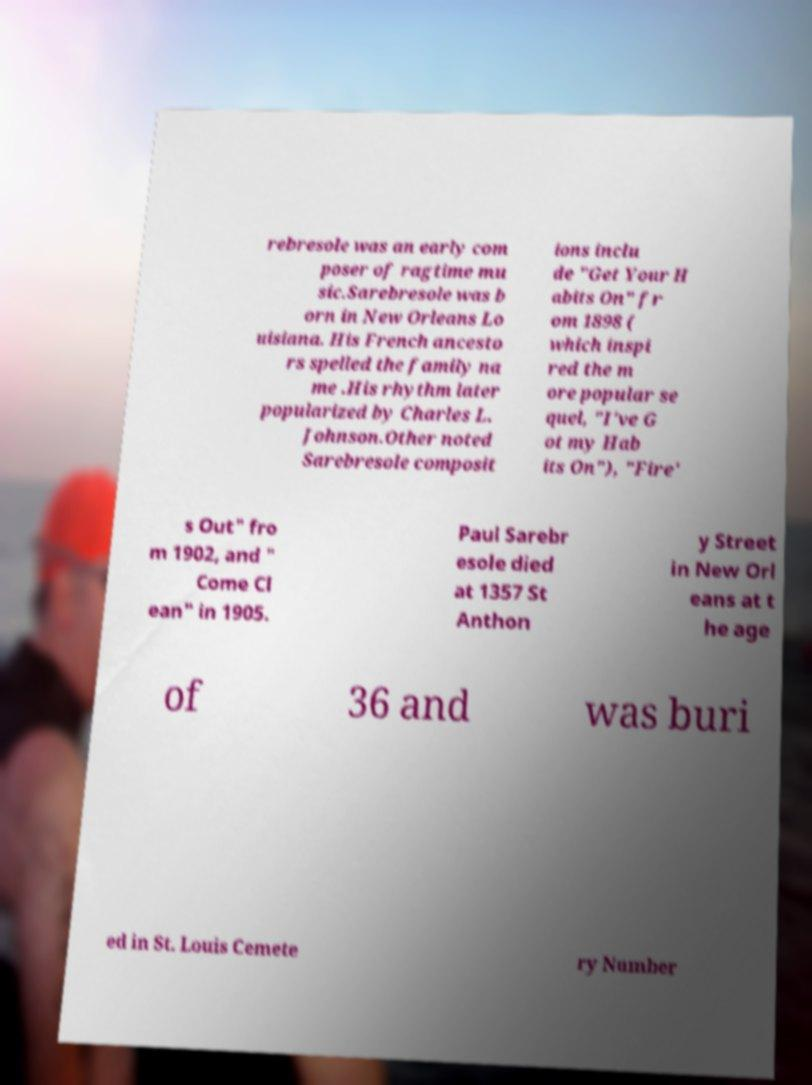For documentation purposes, I need the text within this image transcribed. Could you provide that? rebresole was an early com poser of ragtime mu sic.Sarebresole was b orn in New Orleans Lo uisiana. His French ancesto rs spelled the family na me .His rhythm later popularized by Charles L. Johnson.Other noted Sarebresole composit ions inclu de "Get Your H abits On" fr om 1898 ( which inspi red the m ore popular se quel, "I've G ot my Hab its On"), "Fire' s Out" fro m 1902, and " Come Cl ean" in 1905. Paul Sarebr esole died at 1357 St Anthon y Street in New Orl eans at t he age of 36 and was buri ed in St. Louis Cemete ry Number 